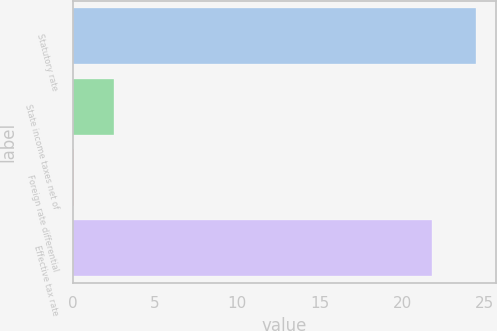<chart> <loc_0><loc_0><loc_500><loc_500><bar_chart><fcel>Statutory rate<fcel>State income taxes net of<fcel>Foreign rate differential<fcel>Effective tax rate<nl><fcel>24.5<fcel>2.54<fcel>0.1<fcel>21.8<nl></chart> 